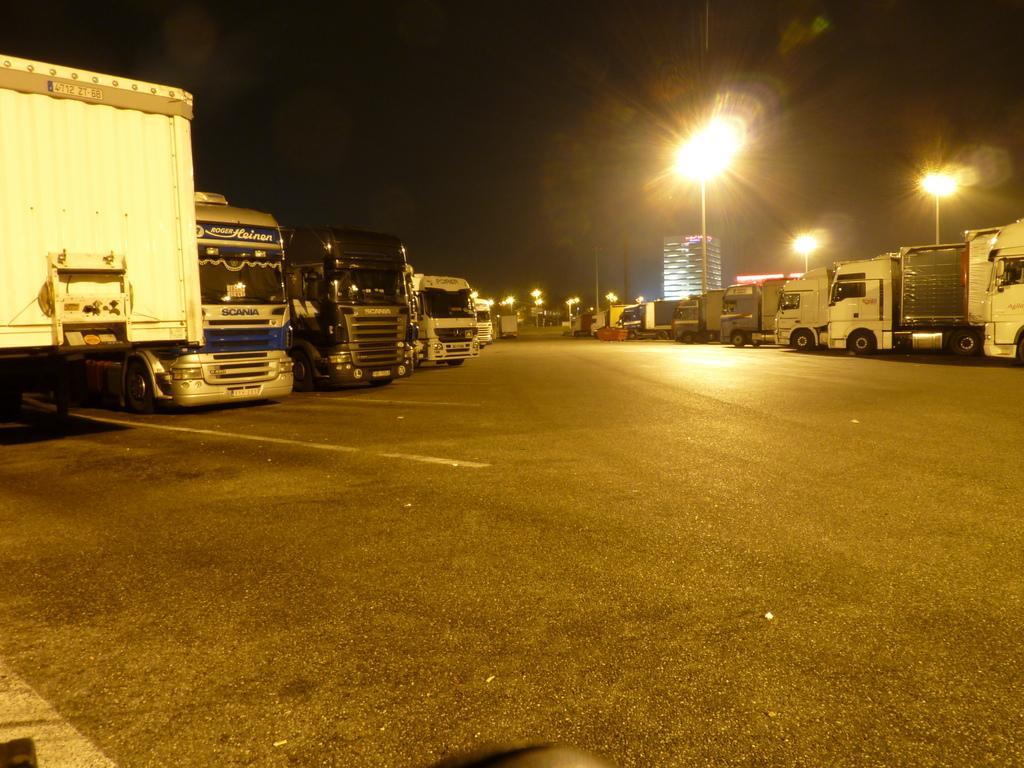Describe this image in one or two sentences. In this picture we can see vehicles on the road, building, poles with lights and some objects and in the background it is dark. 